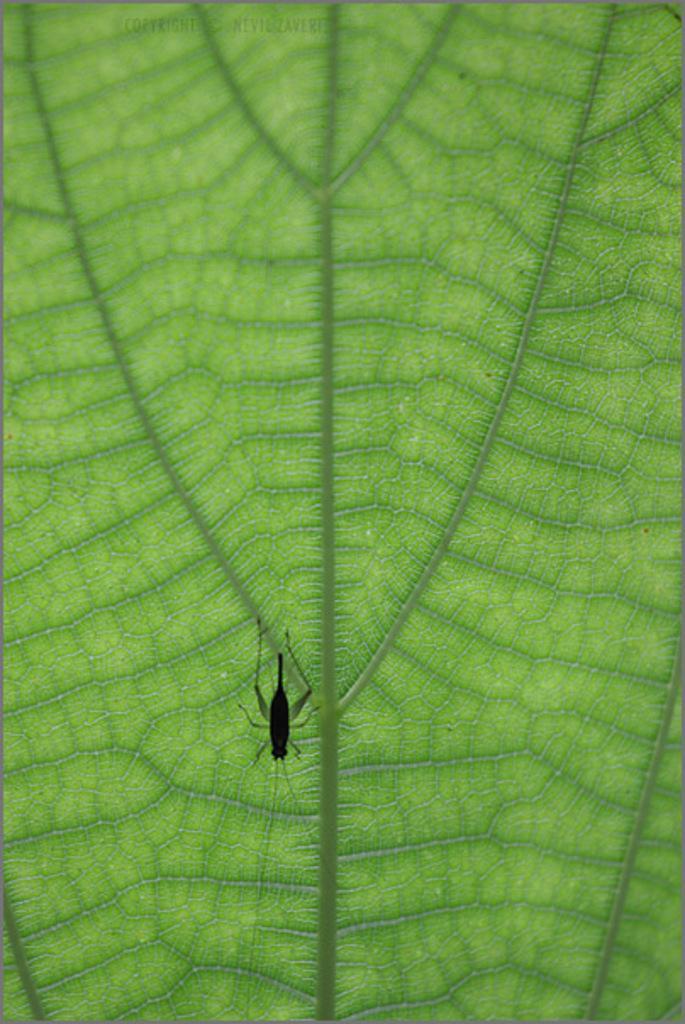How would you summarize this image in a sentence or two? In this picture there is a black color insect on the leaf. At the top there is text. 